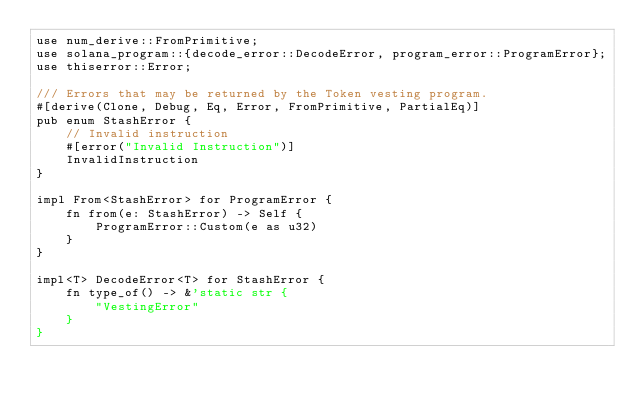<code> <loc_0><loc_0><loc_500><loc_500><_Rust_>use num_derive::FromPrimitive;
use solana_program::{decode_error::DecodeError, program_error::ProgramError};
use thiserror::Error;

/// Errors that may be returned by the Token vesting program.
#[derive(Clone, Debug, Eq, Error, FromPrimitive, PartialEq)]
pub enum StashError {
    // Invalid instruction
    #[error("Invalid Instruction")]
    InvalidInstruction
}

impl From<StashError> for ProgramError {
    fn from(e: StashError) -> Self {
        ProgramError::Custom(e as u32)
    }
}

impl<T> DecodeError<T> for StashError {
    fn type_of() -> &'static str {
        "VestingError"
    }
}</code> 